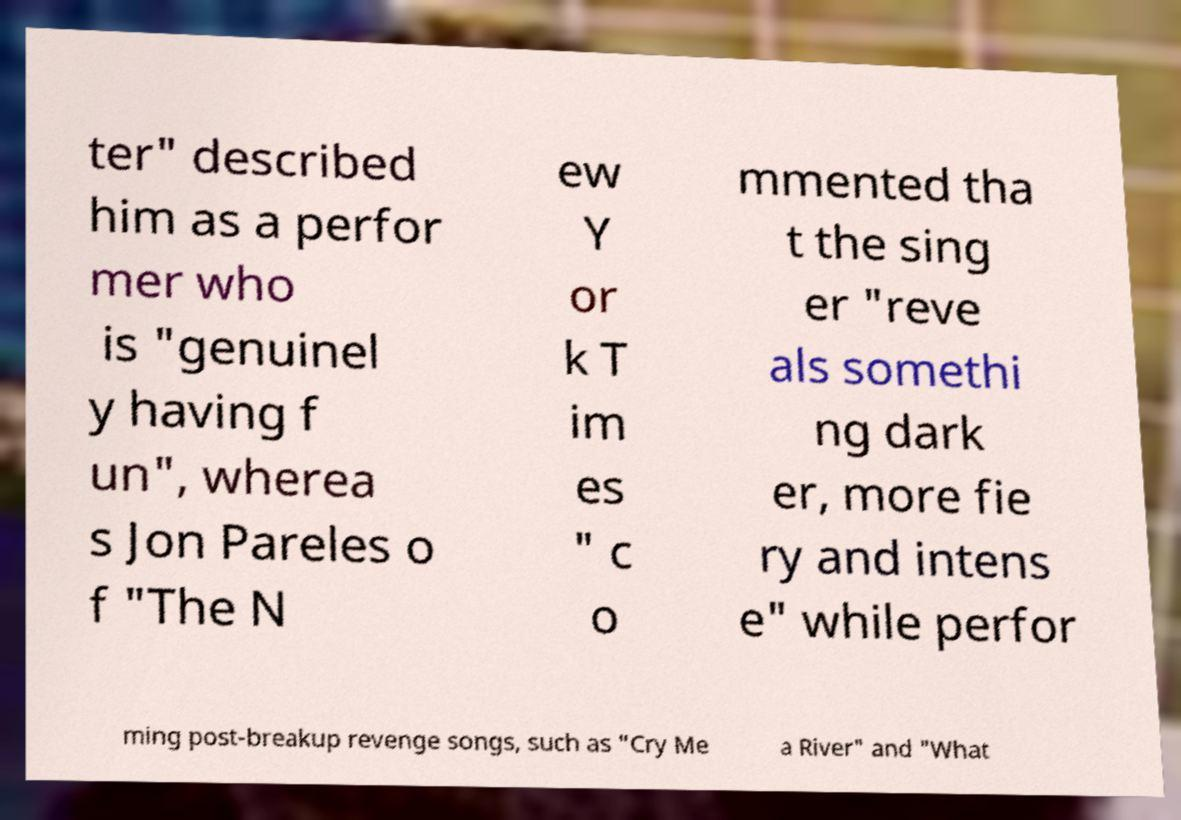Please identify and transcribe the text found in this image. ter" described him as a perfor mer who is "genuinel y having f un", wherea s Jon Pareles o f "The N ew Y or k T im es " c o mmented tha t the sing er "reve als somethi ng dark er, more fie ry and intens e" while perfor ming post-breakup revenge songs, such as "Cry Me a River" and "What 